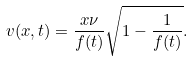<formula> <loc_0><loc_0><loc_500><loc_500>v ( x , t ) = \frac { x \nu } { f ( t ) } \sqrt { 1 - \frac { 1 } { f ( t ) } } .</formula> 